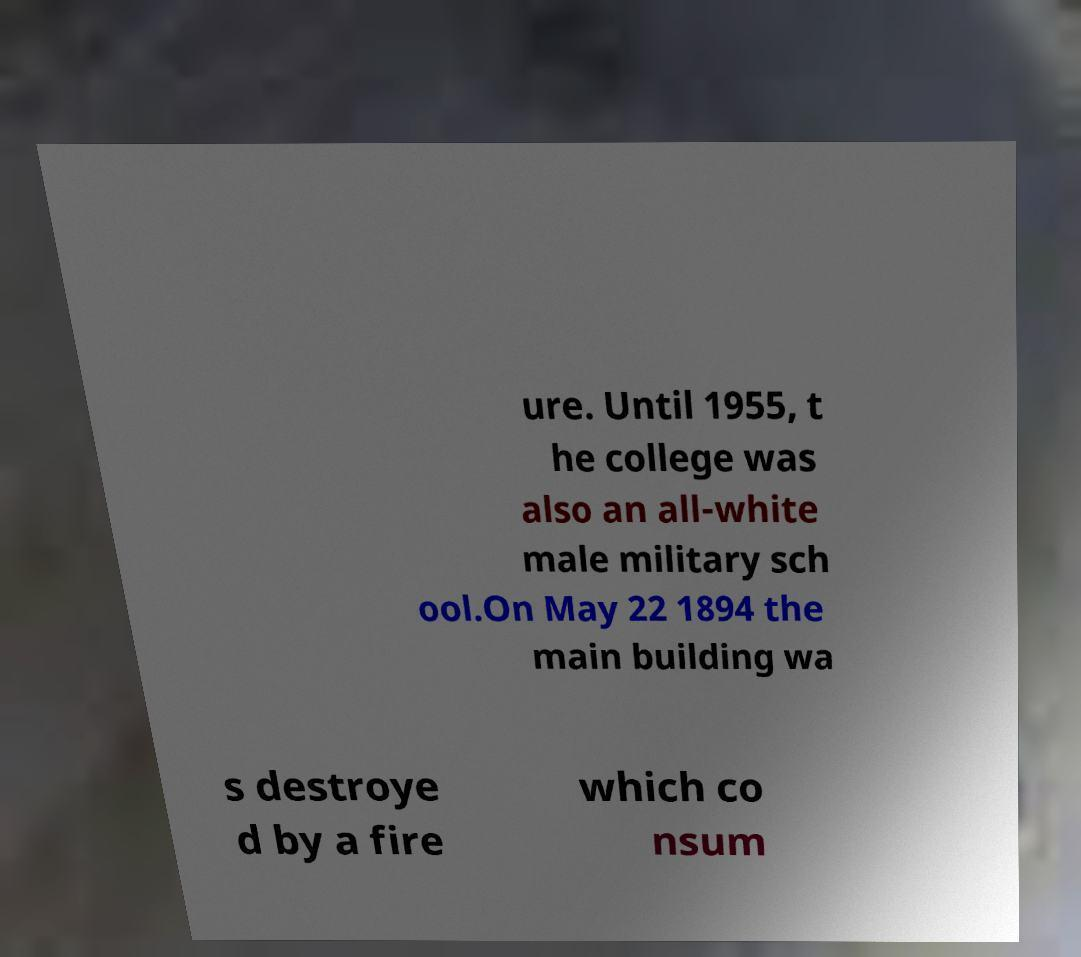Can you read and provide the text displayed in the image?This photo seems to have some interesting text. Can you extract and type it out for me? ure. Until 1955, t he college was also an all-white male military sch ool.On May 22 1894 the main building wa s destroye d by a fire which co nsum 